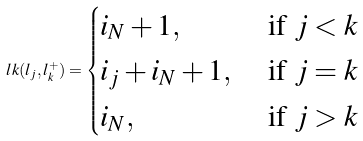<formula> <loc_0><loc_0><loc_500><loc_500>l k ( l _ { j } , l _ { k } ^ { + } ) = \begin{cases} i _ { N } + 1 , & \text { if } j < k \\ i _ { j } + i _ { N } + 1 , & \text { if } j = k \\ i _ { N } , & \text { if } j > k \end{cases}</formula> 